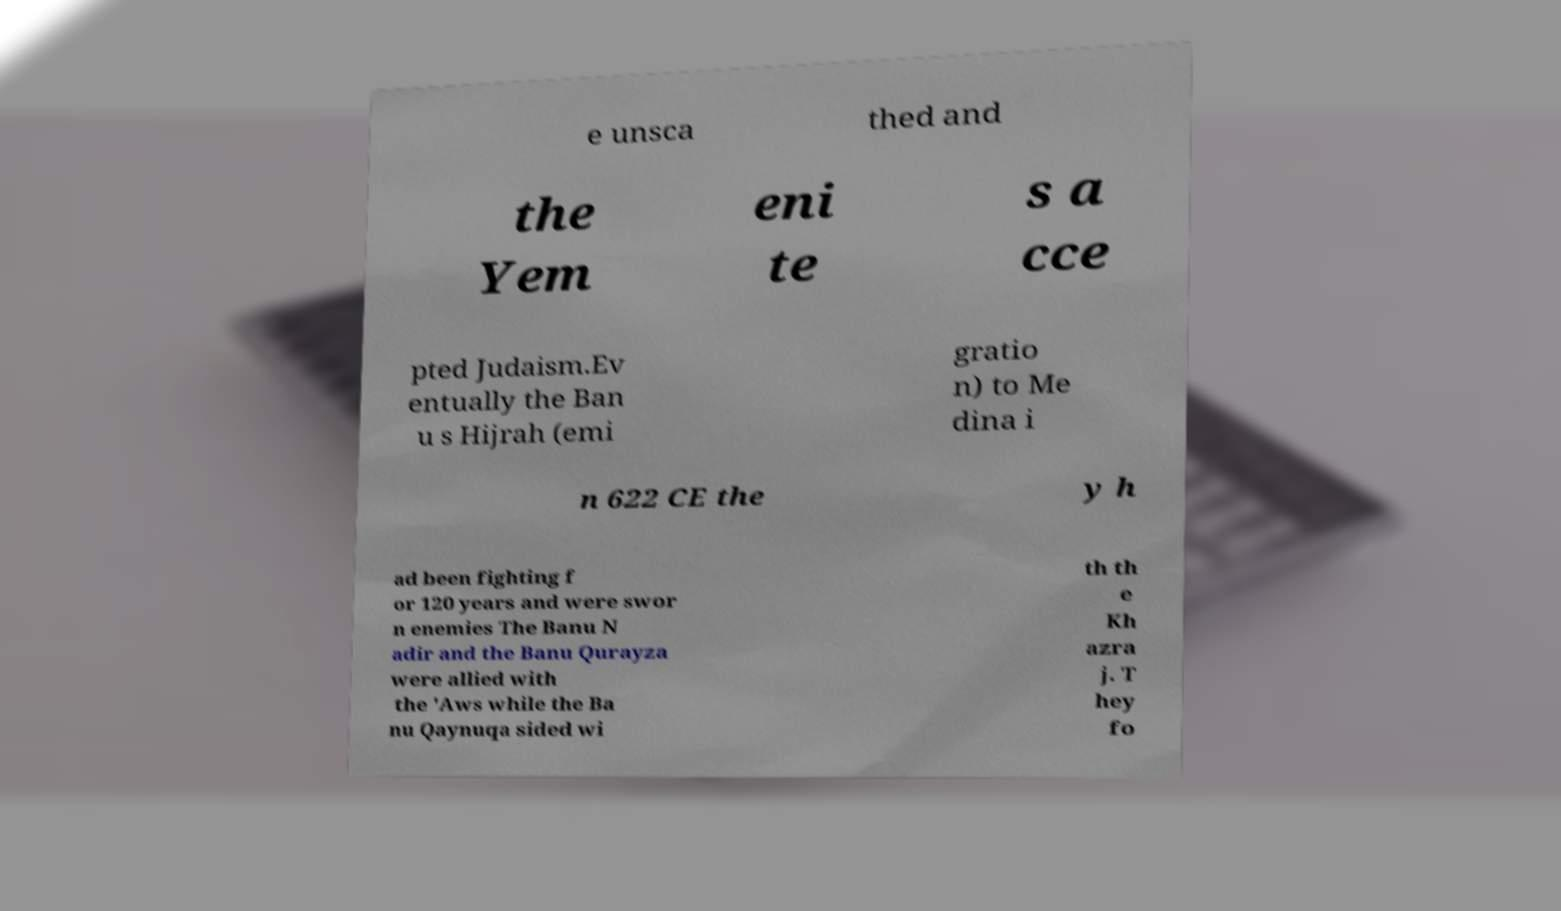There's text embedded in this image that I need extracted. Can you transcribe it verbatim? e unsca thed and the Yem eni te s a cce pted Judaism.Ev entually the Ban u s Hijrah (emi gratio n) to Me dina i n 622 CE the y h ad been fighting f or 120 years and were swor n enemies The Banu N adir and the Banu Qurayza were allied with the 'Aws while the Ba nu Qaynuqa sided wi th th e Kh azra j. T hey fo 